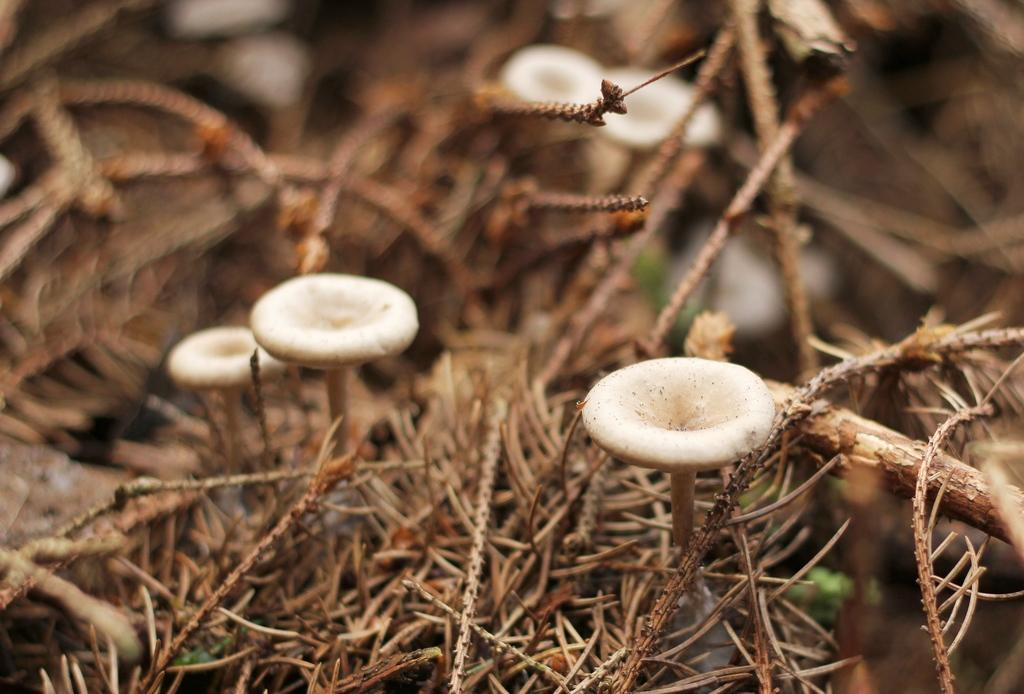What type of fungi can be seen in the image? There are mushrooms in the image. What can be observed in the background of the image? There are dry leaves in the background of the image. What type of action is taking place in the downtown area in the image? There is no downtown area or action present in the image; it features mushrooms and dry leaves. 